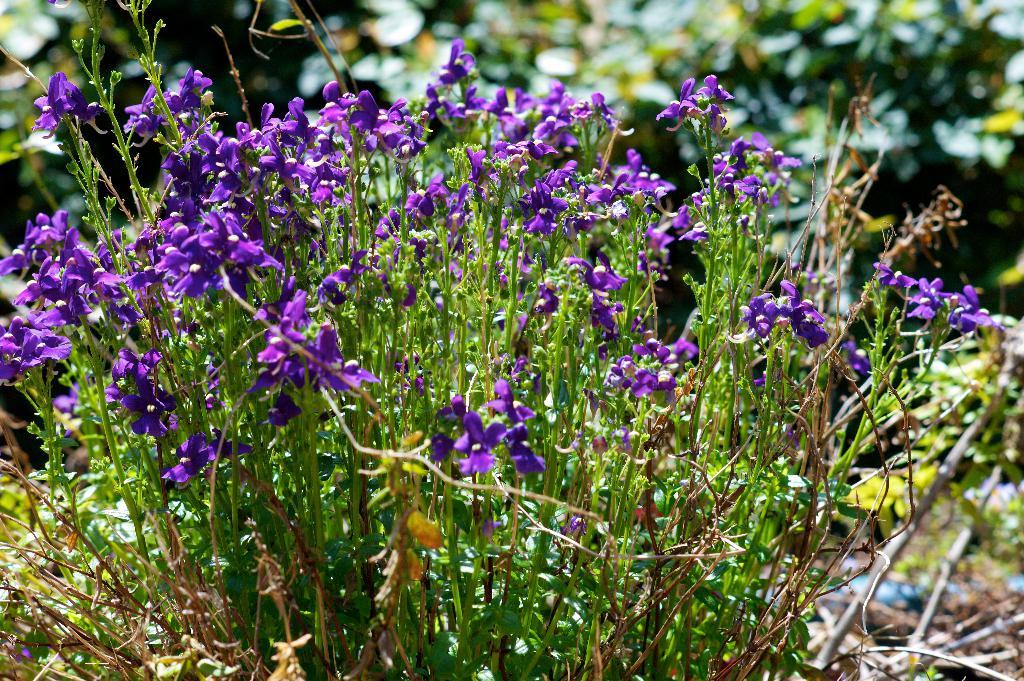What types of vegetation can be seen in the foreground of the picture? There are plants, grass, and flowers in the foreground of the picture. Can you describe the color and texture of the vegetation in the foreground? The plants, grass, and flowers in the foreground are green and have a natural, organic texture. What can be seen in the background of the picture? There is greenery in the background of the picture. What type of nerve can be seen in the picture? There are no nerves present in the picture; it features plants, grass, flowers, and greenery. How many bricks are visible in the picture? There are no bricks present in the picture; it features plants, grass, flowers, and greenery. 